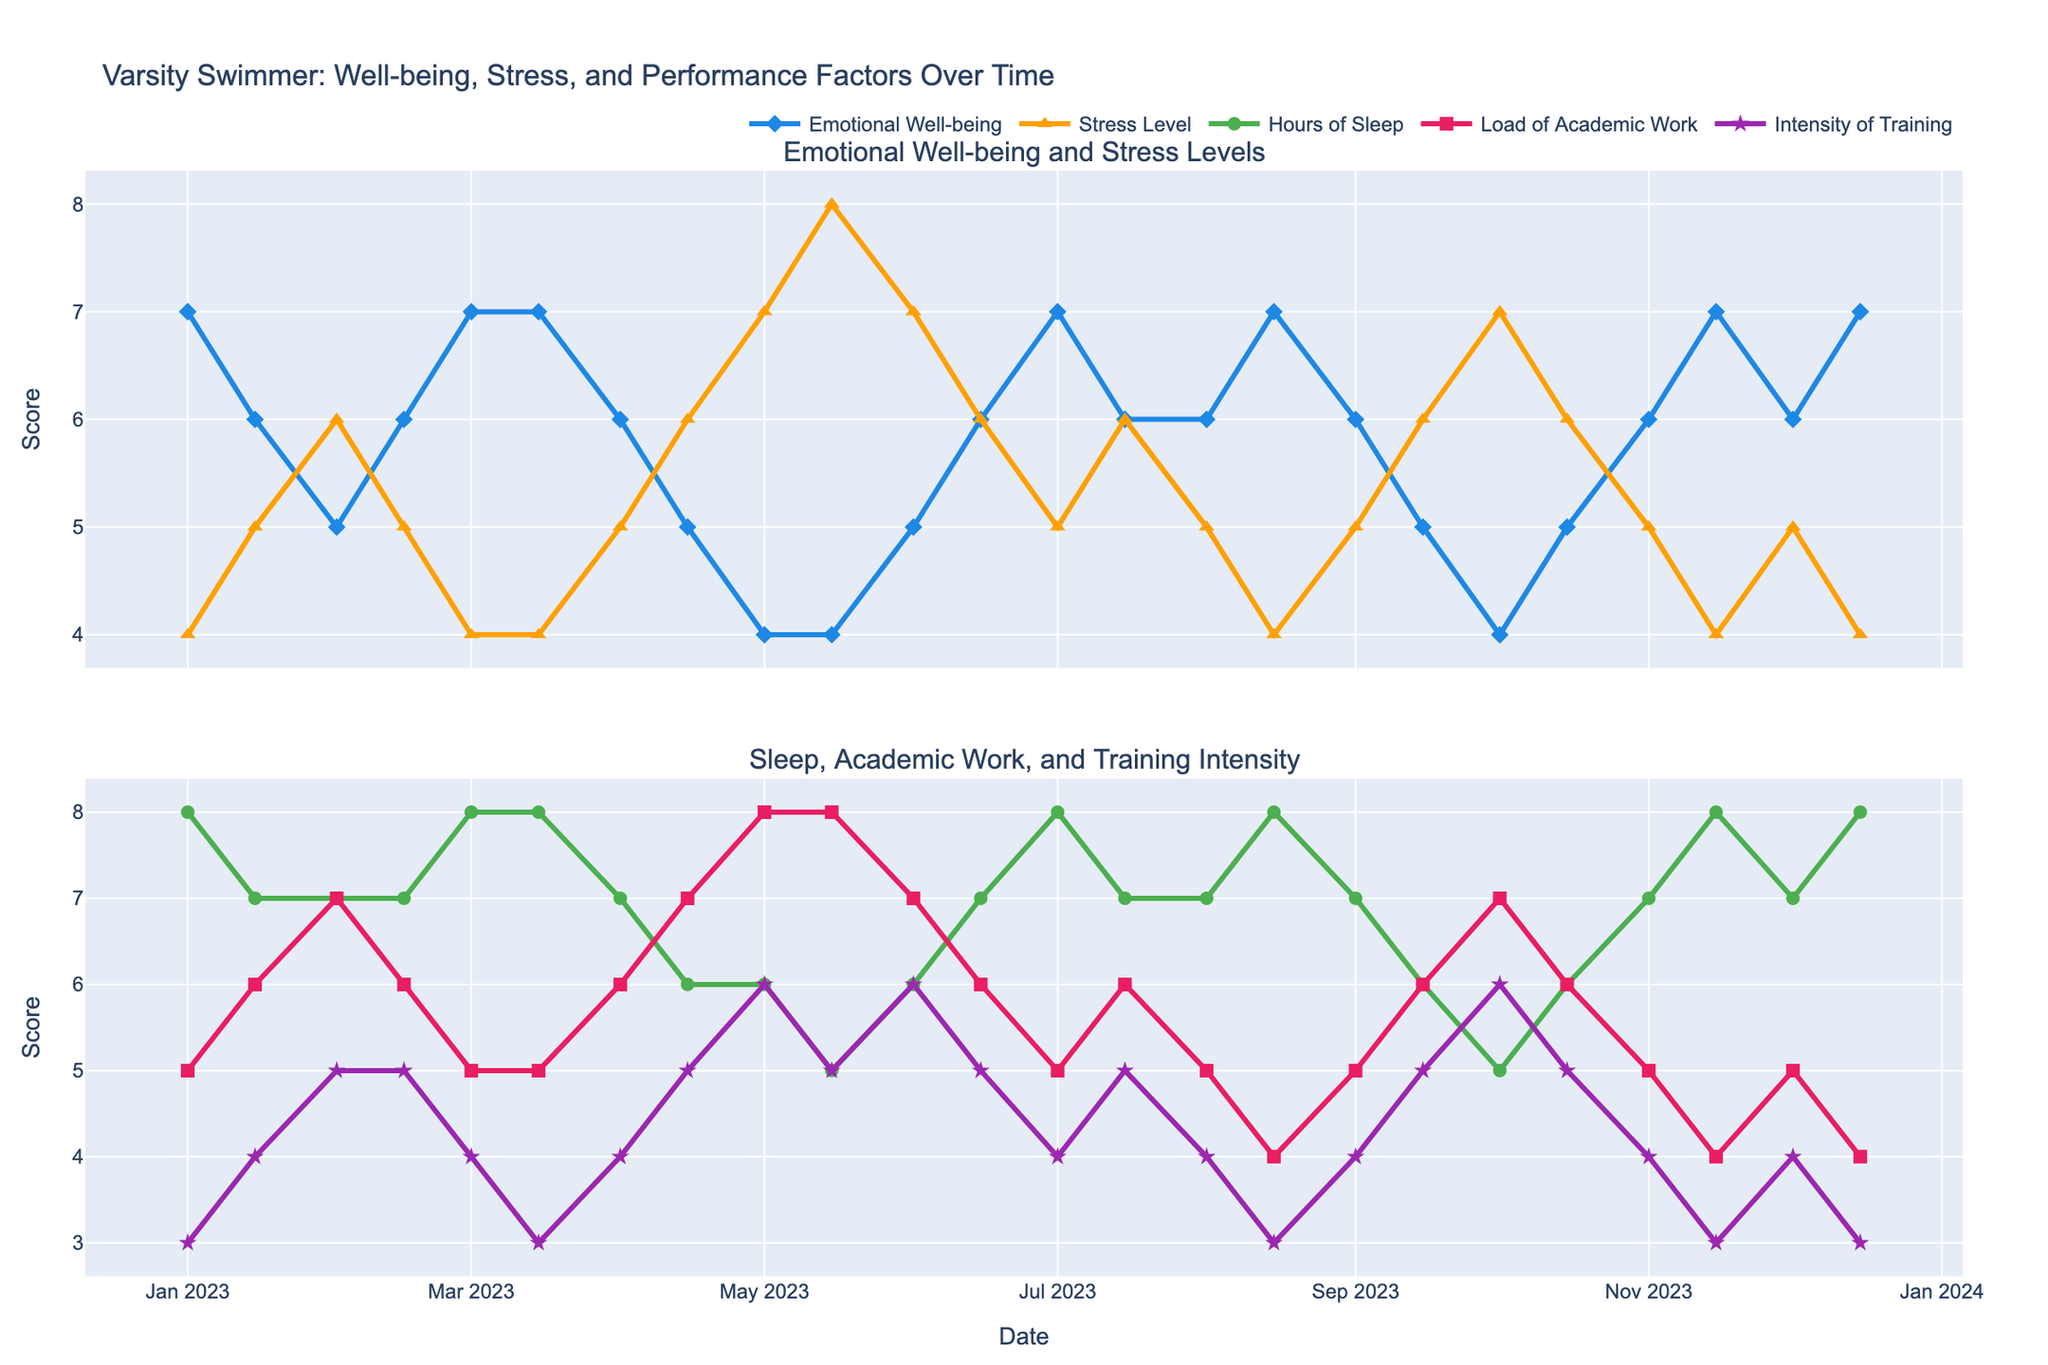How many total points are plotted for "Emotional Well-being"? Count the number of data points in the plot regarding Emotional Well-being. Since the data contains 24 dates and each date has a recorded Emotional Well-being score, there are 24 data points.
Answer: 24 Describe the overall trend of "Stress Level" throughout the academic year. Analyze the Stress Level trace by observing the overall pattern of increases and decreases over time. Stress levels start moderately, increase around May, peak in mid-May, then decrease towards July, increase again from September, and decrease towards the end of the year.
Answer: Fluctuates with peaks in mid-May and early October What is the difference between the Emotional Well-being on January 1st and on May 15th? The Emotional Well-being on January 1st is 7, while on May 15th it is 4. The difference is calculated as 7 - 4.
Answer: 3 When is the "Hours of Sleep" at its lowest? Identify the lowest point on the Hours of Sleep plot. The lowest Hours of Sleep value is observed on May 15th and October 1st, with a score of 5.
Answer: May 15 and October 1 Compare the trend of "Load of Academic Work" and "Intensity of Training" from January to December. Observe the plots for Load of Academic Work and Intensity of Training over time. The Load of Academic Work generally increases towards mid-year (peaking in May), then decreases, while the Intensity of Training follows a similar pattern but peaks slightly later, in June.
Answer: Both increase mid-year, peaking around May for academic work and June for training What's the relationship between "Hours of Sleep" and "Stress Level" over the year? Analyze the two graphs to understand if there is any correlation. Generally, a decrease in Hours of Sleep is followed by an increase in Stress Level, suggesting an inverse relationship.
Answer: Inverse relationship Between January and December, when are the "Emotional Well-being" and "Stress Level" closest to each other? Observe the two plots to find points where the values are closest. The values are closest on around June 1st, where Emotional Well-being is 5 and Stress Level is 7.
Answer: June 1 What is the average "Emotional Well-being" score during the first quarter (January to March)? Calculate the average Emotional Well-being score for January 1st, January 15th, February 1st, February 15th, March 1st, and March 15th. The scores are 7, 6, 5, 6, 7, and 7. Average = (7+6+5+6+7+7)/6 = 6.33.
Answer: 6.33 Which month shows the highest variability in Stress Level? Check the variability in Stress Level across different months. May shows high variability where the Stress Level moves from 7 on May 1st to 8 on May 15th.
Answer: May 